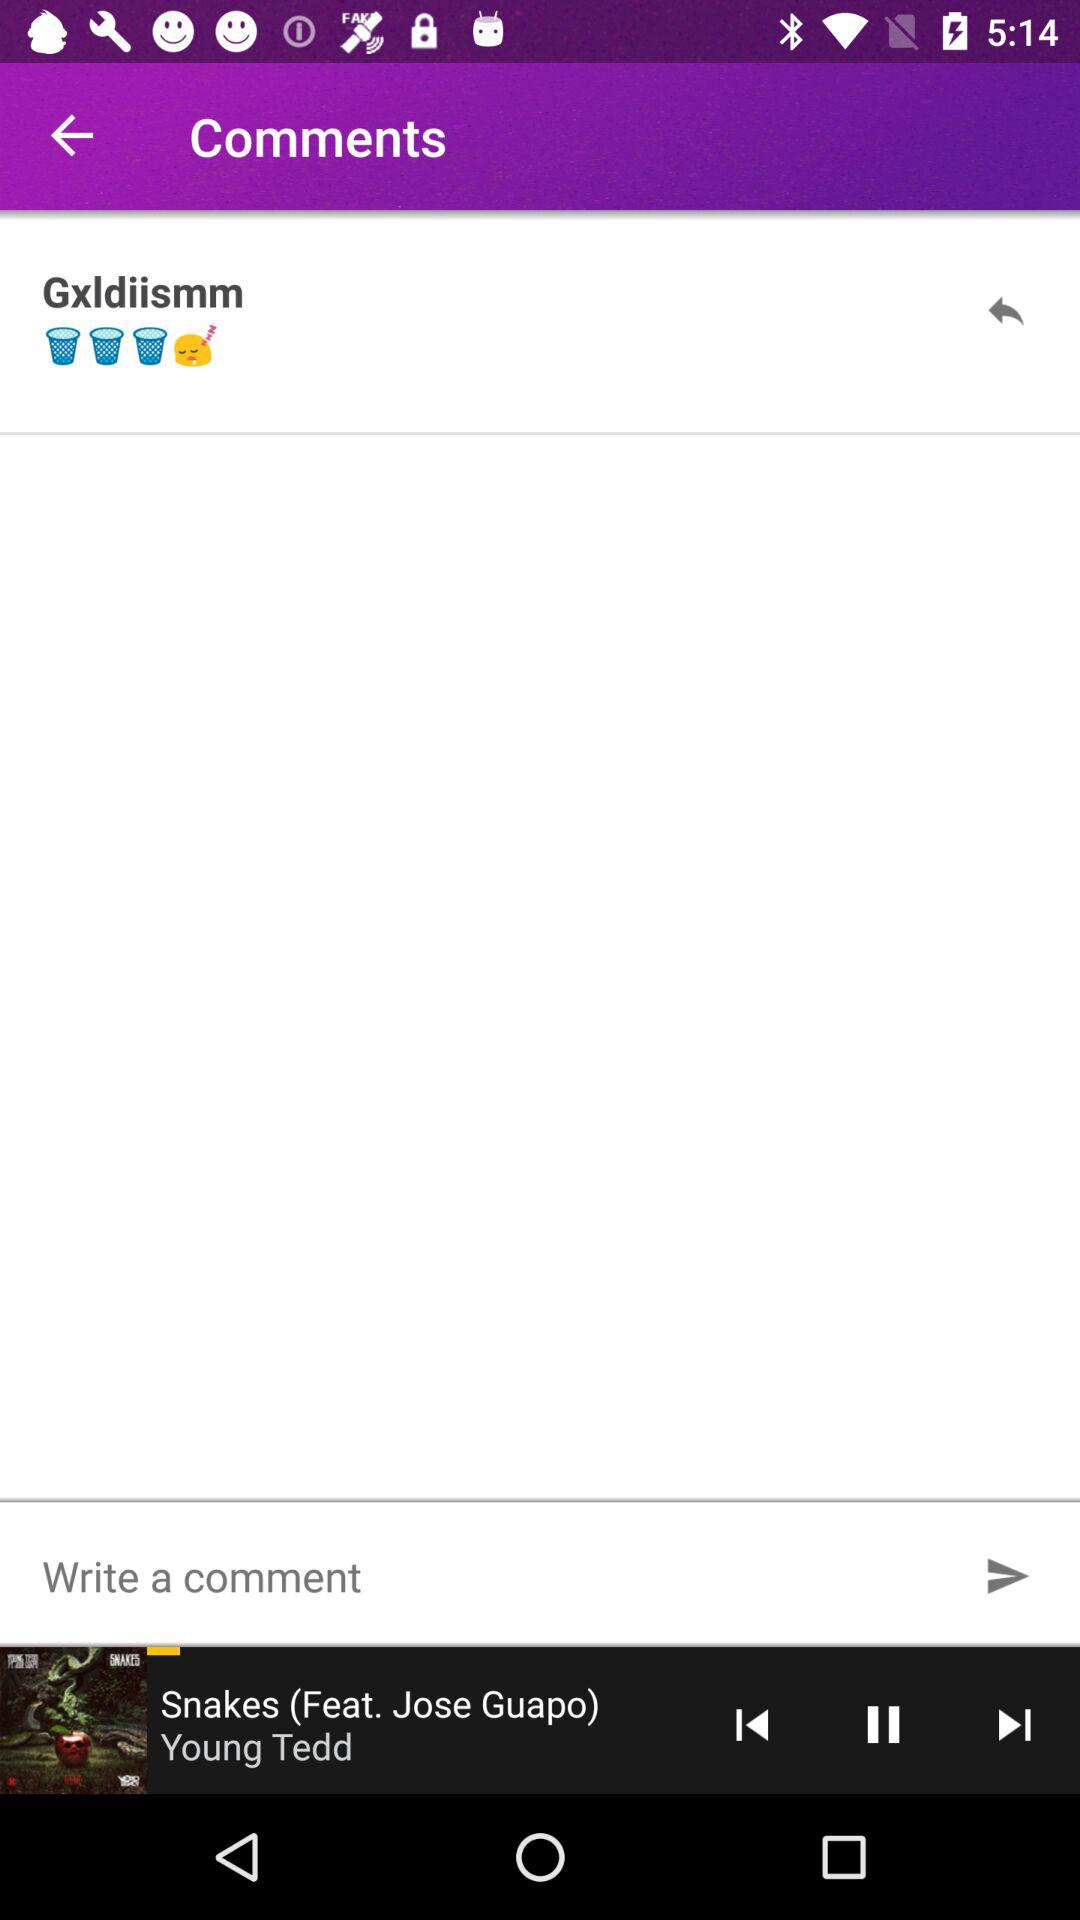How many emojis are there on the screen?
Answer the question using a single word or phrase. 3 